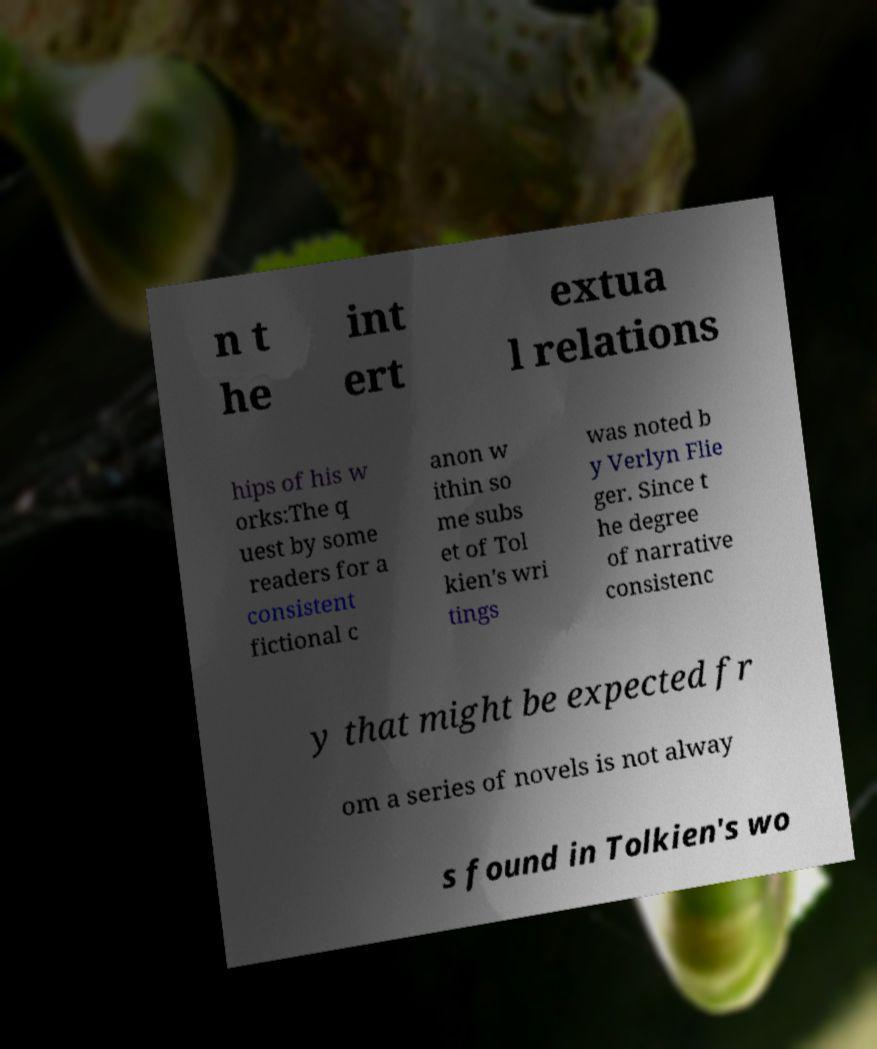Can you accurately transcribe the text from the provided image for me? n t he int ert extua l relations hips of his w orks:The q uest by some readers for a consistent fictional c anon w ithin so me subs et of Tol kien's wri tings was noted b y Verlyn Flie ger. Since t he degree of narrative consistenc y that might be expected fr om a series of novels is not alway s found in Tolkien's wo 